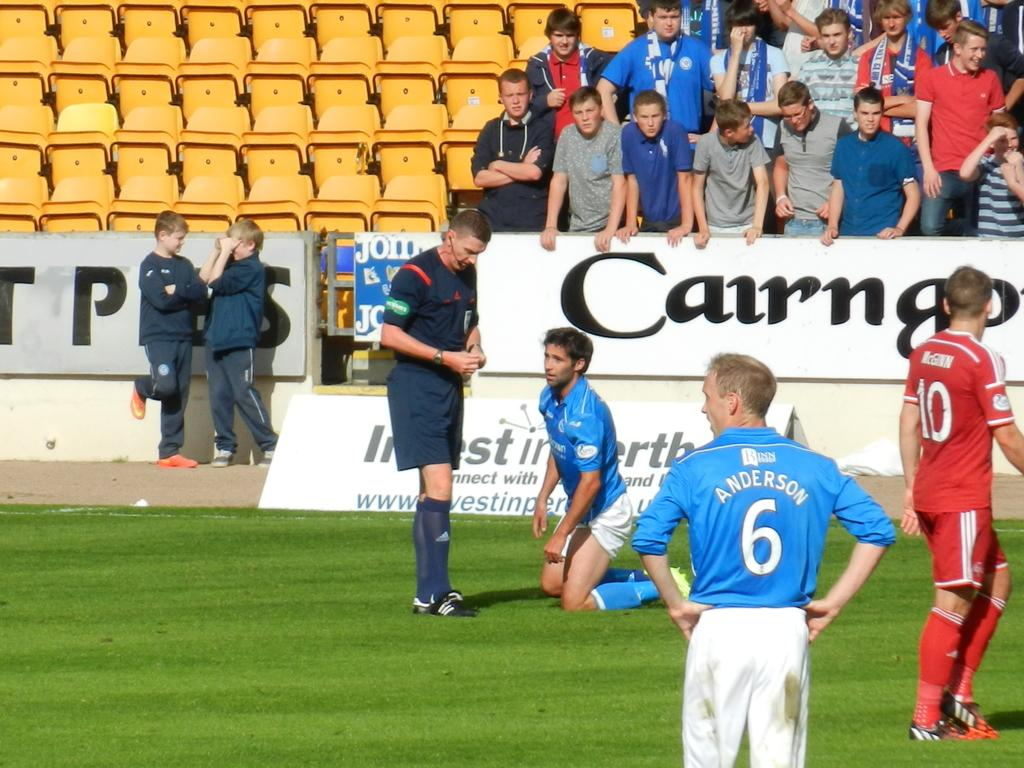Provide a one-sentence caption for the provided image. A soccer player kneeling and another one wearing a blue shirt that says Anderson on the back. 